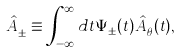<formula> <loc_0><loc_0><loc_500><loc_500>\hat { A } _ { \pm } ^ { \dagger } \equiv \int _ { - \infty } ^ { \infty } d t \Psi _ { \pm } ( t ) \hat { A } _ { \theta } ^ { \dagger } ( t ) ,</formula> 